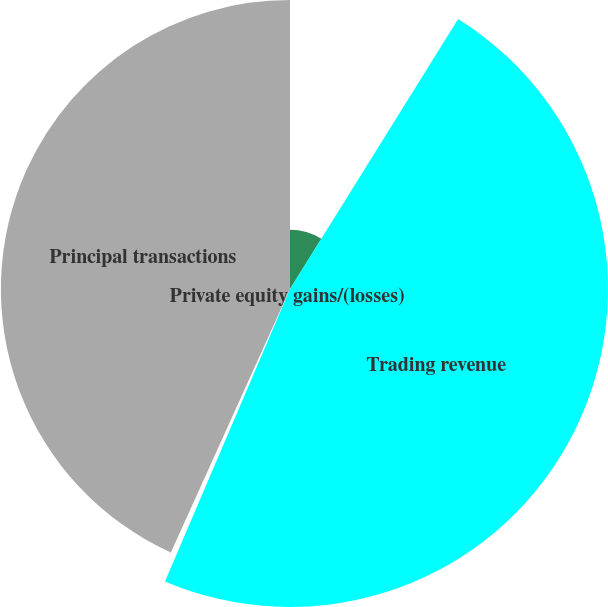Convert chart. <chart><loc_0><loc_0><loc_500><loc_500><pie_chart><fcel>Year ended December 31 (in<fcel>Trading revenue<fcel>Private equity gains/(losses)<fcel>Principal transactions<nl><fcel>8.87%<fcel>47.56%<fcel>0.33%<fcel>43.24%<nl></chart> 